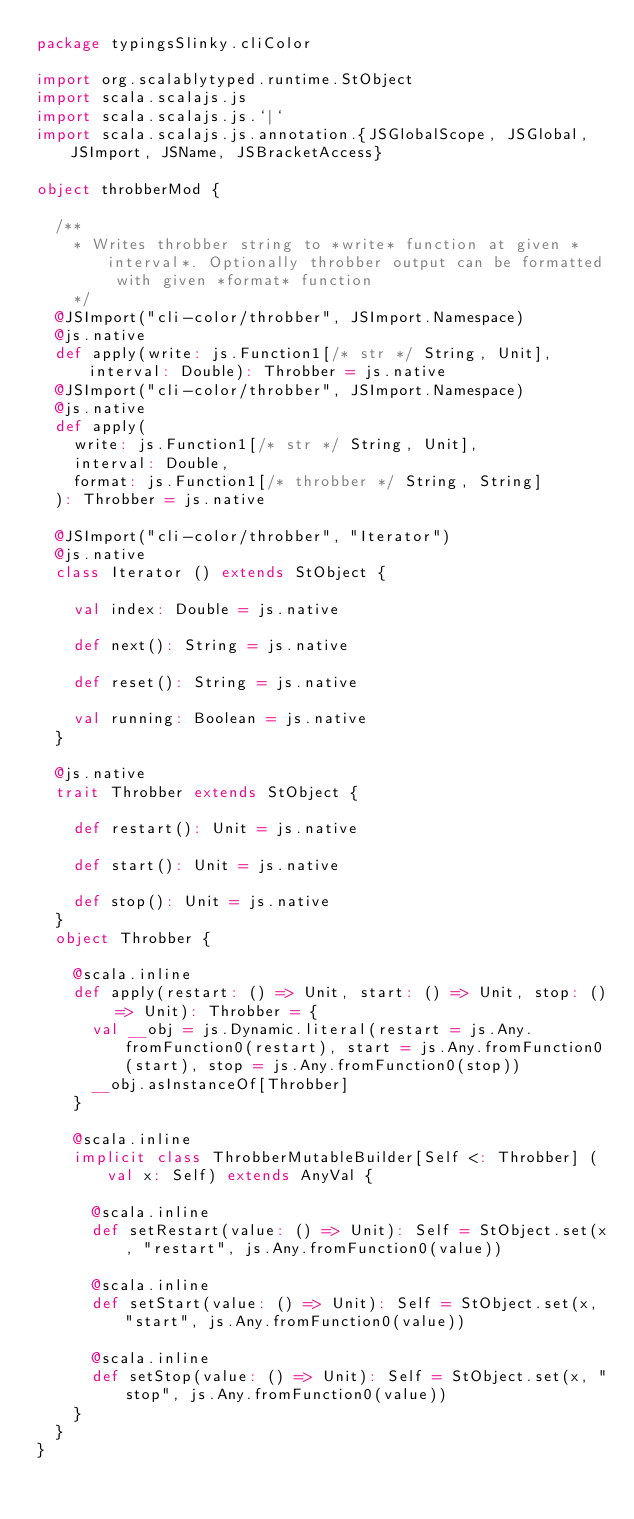Convert code to text. <code><loc_0><loc_0><loc_500><loc_500><_Scala_>package typingsSlinky.cliColor

import org.scalablytyped.runtime.StObject
import scala.scalajs.js
import scala.scalajs.js.`|`
import scala.scalajs.js.annotation.{JSGlobalScope, JSGlobal, JSImport, JSName, JSBracketAccess}

object throbberMod {
  
  /**
    * Writes throbber string to *write* function at given *interval*. Optionally throbber output can be formatted with given *format* function
    */
  @JSImport("cli-color/throbber", JSImport.Namespace)
  @js.native
  def apply(write: js.Function1[/* str */ String, Unit], interval: Double): Throbber = js.native
  @JSImport("cli-color/throbber", JSImport.Namespace)
  @js.native
  def apply(
    write: js.Function1[/* str */ String, Unit],
    interval: Double,
    format: js.Function1[/* throbber */ String, String]
  ): Throbber = js.native
  
  @JSImport("cli-color/throbber", "Iterator")
  @js.native
  class Iterator () extends StObject {
    
    val index: Double = js.native
    
    def next(): String = js.native
    
    def reset(): String = js.native
    
    val running: Boolean = js.native
  }
  
  @js.native
  trait Throbber extends StObject {
    
    def restart(): Unit = js.native
    
    def start(): Unit = js.native
    
    def stop(): Unit = js.native
  }
  object Throbber {
    
    @scala.inline
    def apply(restart: () => Unit, start: () => Unit, stop: () => Unit): Throbber = {
      val __obj = js.Dynamic.literal(restart = js.Any.fromFunction0(restart), start = js.Any.fromFunction0(start), stop = js.Any.fromFunction0(stop))
      __obj.asInstanceOf[Throbber]
    }
    
    @scala.inline
    implicit class ThrobberMutableBuilder[Self <: Throbber] (val x: Self) extends AnyVal {
      
      @scala.inline
      def setRestart(value: () => Unit): Self = StObject.set(x, "restart", js.Any.fromFunction0(value))
      
      @scala.inline
      def setStart(value: () => Unit): Self = StObject.set(x, "start", js.Any.fromFunction0(value))
      
      @scala.inline
      def setStop(value: () => Unit): Self = StObject.set(x, "stop", js.Any.fromFunction0(value))
    }
  }
}
</code> 